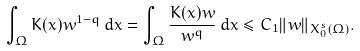<formula> <loc_0><loc_0><loc_500><loc_500>\int _ { \Omega } K ( x ) w ^ { 1 - q } \, d x = \int _ { \Omega } \frac { K ( x ) w } { w ^ { q } } \, d x \leq C _ { 1 } \| w \| _ { X _ { 0 } ^ { s } ( \Omega ) } .</formula> 